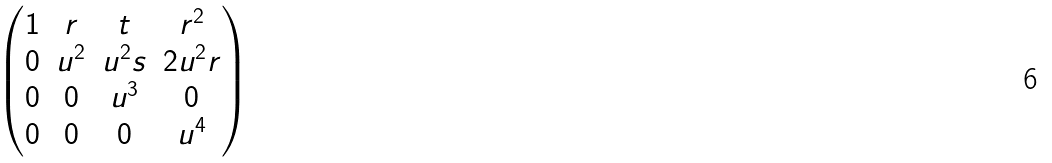Convert formula to latex. <formula><loc_0><loc_0><loc_500><loc_500>\begin{pmatrix} 1 & r & t & r ^ { 2 } \\ 0 & u ^ { 2 } & u ^ { 2 } s & 2 u ^ { 2 } r \\ 0 & 0 & u ^ { 3 } & 0 \\ 0 & 0 & 0 & u ^ { 4 } \end{pmatrix}</formula> 